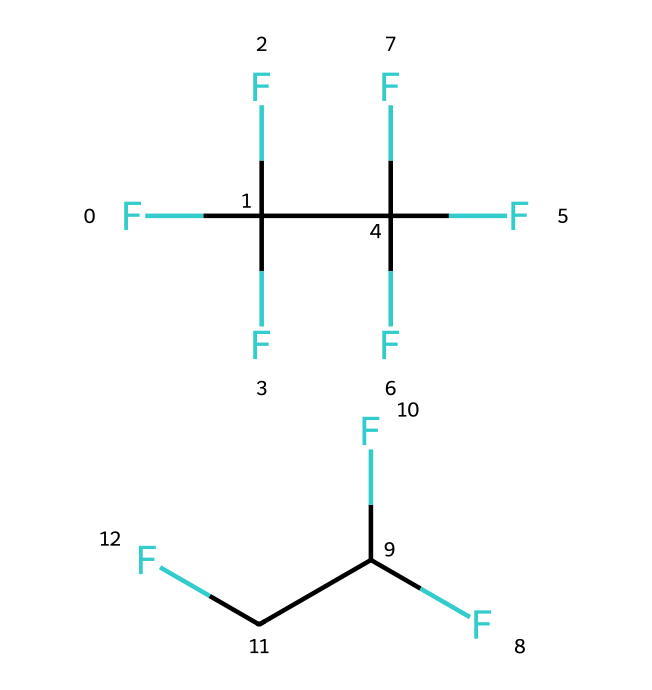How many carbon atoms are present in R-410A? By analyzing the provided SMILES representation, there are two separate parts indicating the presence of carbon. Each part shows multiple carbon atoms; counted carefully, there are a total of 6 carbon atoms.
Answer: six What is the molecular formula of R-410A? The chemical structure can be deduced to form the molecular formula by counting the atoms of each element based on the SMILES representation, leading us to C6H12F24.
Answer: C6H12F24 Which type of chemical bond is predominantly present in R-410A? The presence of fluorine atoms and their arrangement with carbon suggests that the primary bonds in R-410A are covalent bonds, especially as carbon bonds with fluorine.
Answer: covalent Is R-410A a single chemical or a mixture? The presence of a dot (.) in the SMILES indicates that R-410A is a mixture (zeotropic blend) of two refrigerants, not a single compound.
Answer: mixture What impact does the fluorine content have on the properties of R-410A? The high proportion of fluorine contributes to lower ozone depletion potential and stronger greenhouse gas characteristics, reflecting its environmental impact as a refrigerant.
Answer: environmental impact What is the primary application of R-410A? The chemical structure and properties make R-410A suitable for use in air conditioning and refrigeration systems, which is its primary application.
Answer: air conditioning 